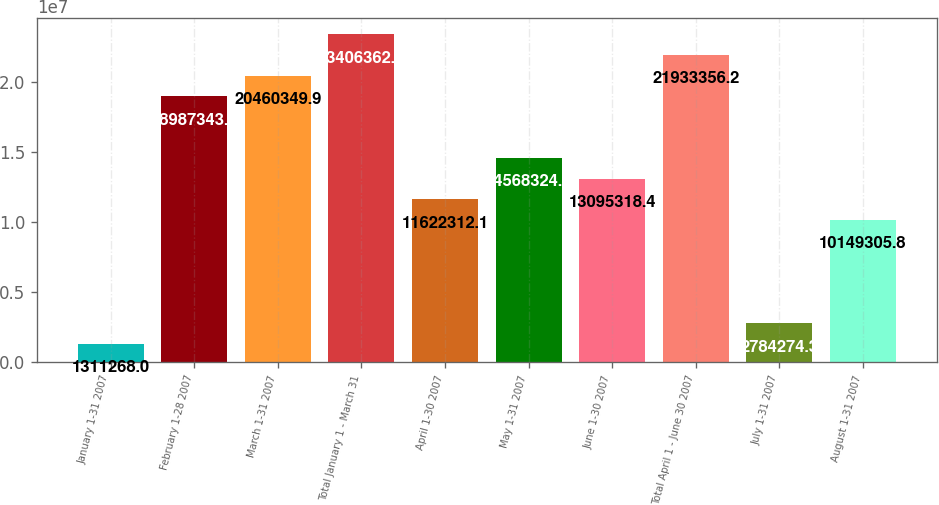<chart> <loc_0><loc_0><loc_500><loc_500><bar_chart><fcel>January 1-31 2007<fcel>February 1-28 2007<fcel>March 1-31 2007<fcel>Total January 1 - March 31<fcel>April 1-30 2007<fcel>May 1-31 2007<fcel>June 1-30 2007<fcel>Total April 1 - June 30 2007<fcel>July 1-31 2007<fcel>August 1-31 2007<nl><fcel>1.31127e+06<fcel>1.89873e+07<fcel>2.04603e+07<fcel>2.34064e+07<fcel>1.16223e+07<fcel>1.45683e+07<fcel>1.30953e+07<fcel>2.19334e+07<fcel>2.78427e+06<fcel>1.01493e+07<nl></chart> 